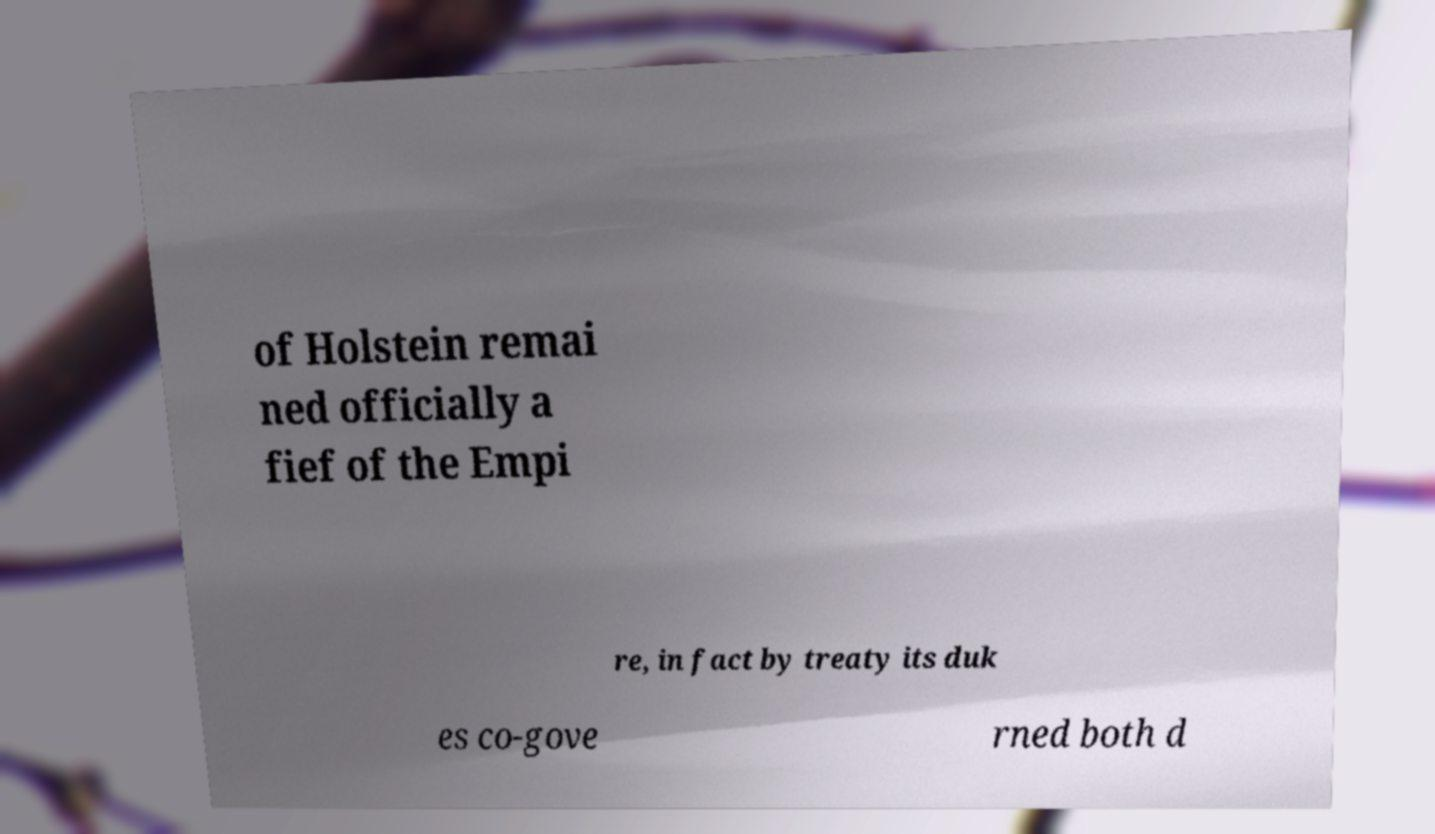Can you read and provide the text displayed in the image?This photo seems to have some interesting text. Can you extract and type it out for me? of Holstein remai ned officially a fief of the Empi re, in fact by treaty its duk es co-gove rned both d 